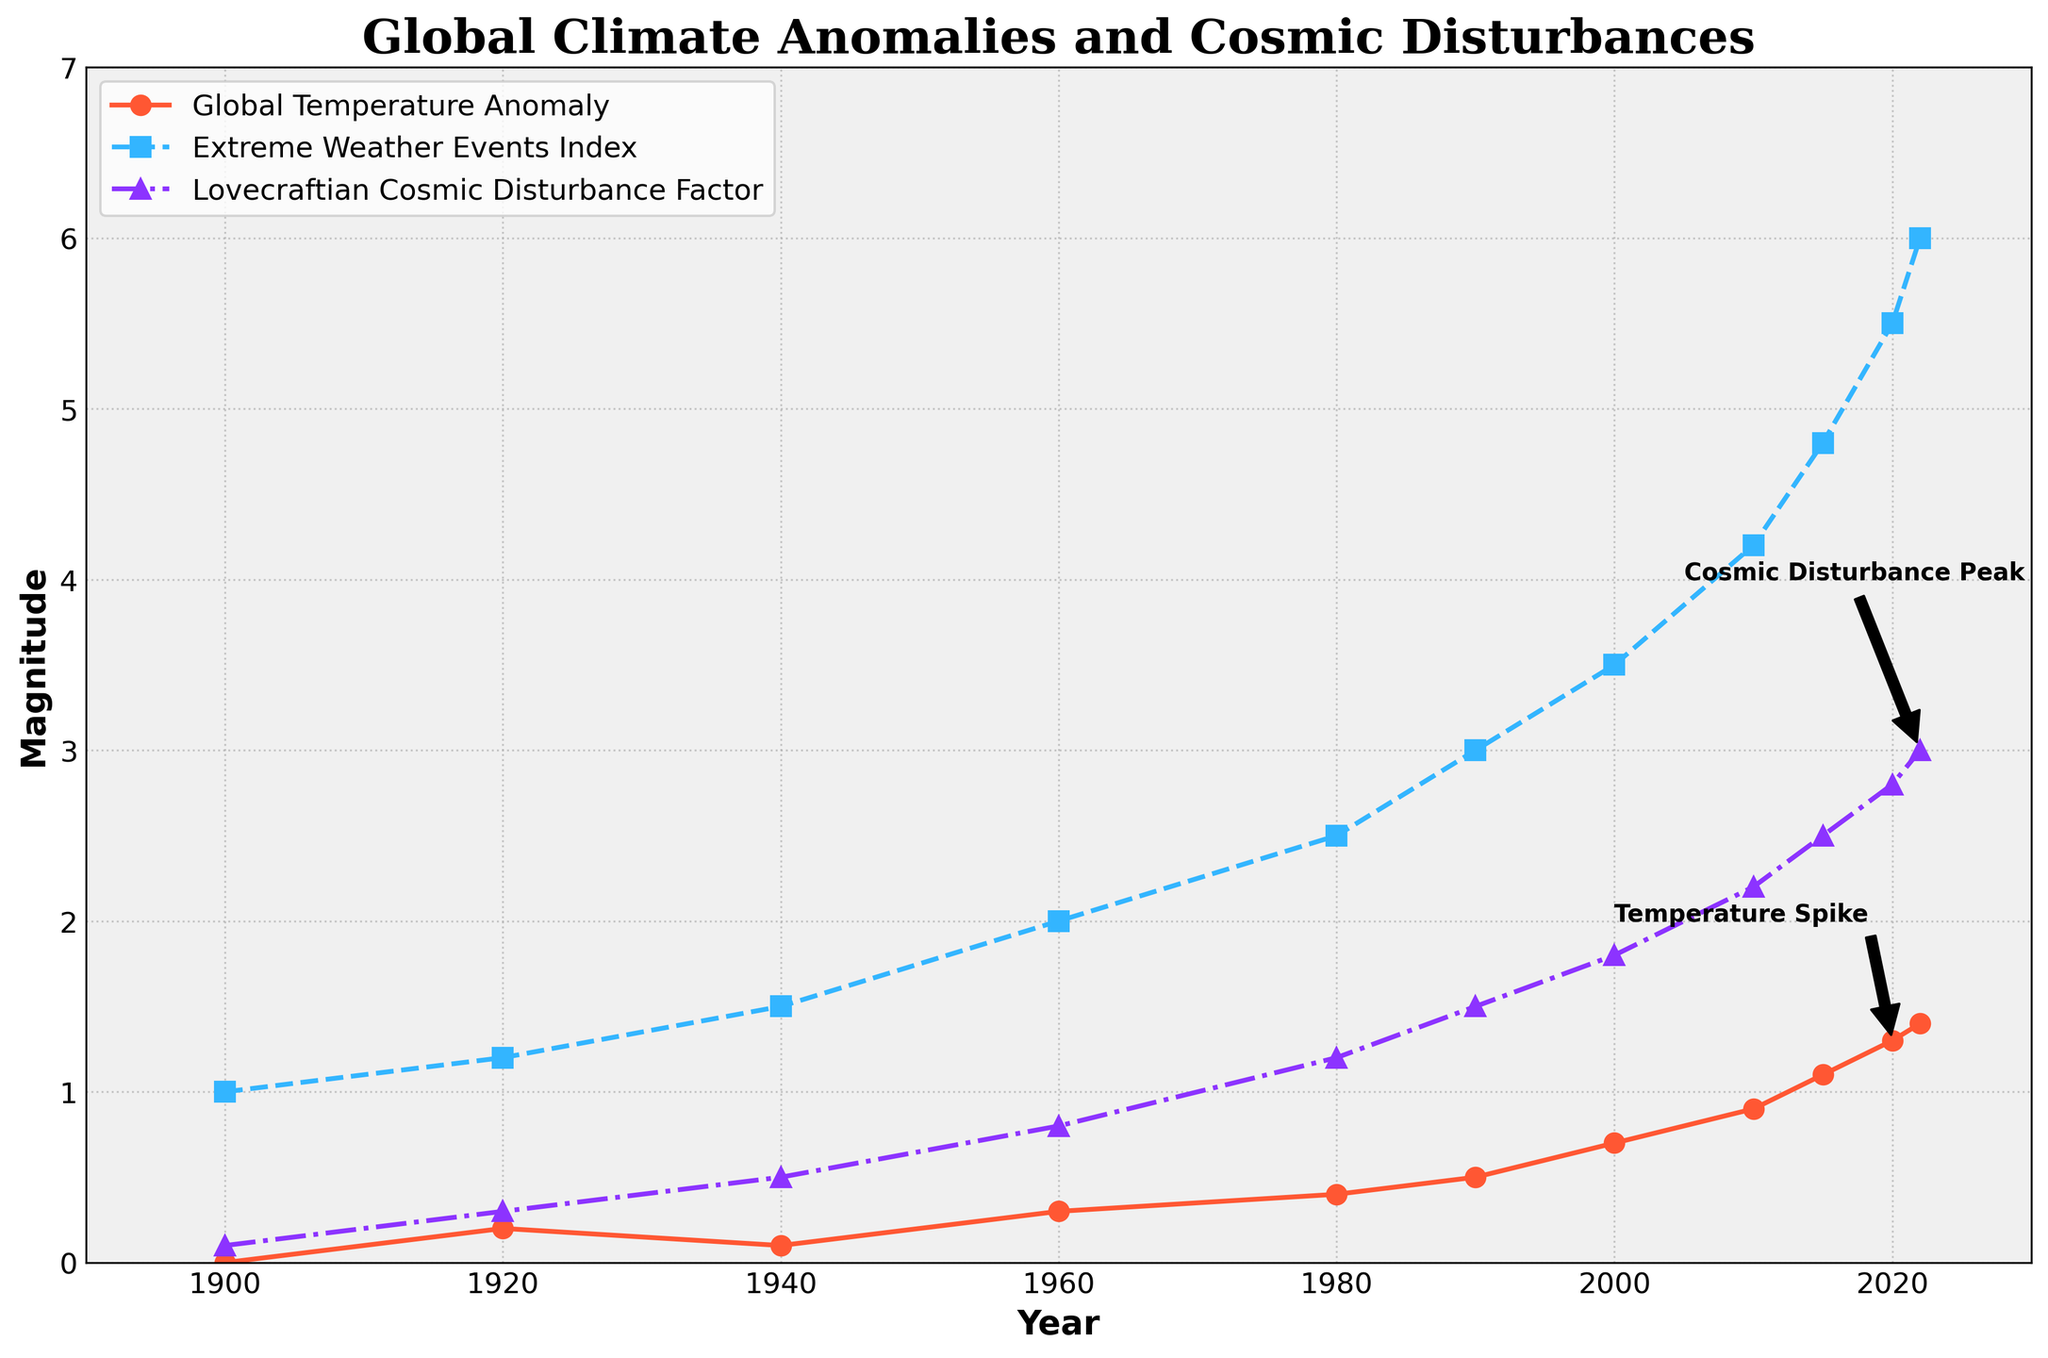what is the range of the Global Temperature Anomaly from 1900 to 2022? The range is the difference between the maximum and minimum values. From the figure, the minimum value is 0.0 in 1900, and the maximum value is 1.4 in 2022. Therefore, the range is 1.4 - 0.0 = 1.4
Answer: 1.4 which year shows a noticeable spike in the Extreme Weather Events Index? From the figure, a noticeable spike in the Extreme Weather Events Index can be seen around 2010, where the index jumps from 3.5 in 2000 to 4.2 in 2010.
Answer: 2010 compare the trends: did the Global Temperature Anomaly or the Extreme Weather Events Index increase more rapidly between 1980 and 2020? To determine which increased more rapidly, we need to compare the changes in both variables. The Global Temperature Anomaly increased from 0.4 in 1980 to 1.3 in 2020, an increase of 0.9. The Extreme Weather Events Index increased from 2.5 in 1980 to 5.5 in 2020, an increase of 3.0. The Extreme Weather Events Index increased more rapidly.
Answer: Extreme Weather Events Index what is the relationship between the Lovecraftian Cosmic Disturbance Factor and the Global Temperature Anomaly in 2022? In 2022, the Lovecraftian Cosmic Disturbance Factor is 3.0, and the Global Temperature Anomaly is 1.4. The relationship observed is that both increase over time, suggesting a potential correlation or dependency.
Answer: Both increased which index shows the highest variability throughout the period 1900-2022? Variability can be assessed by observing the fluctuations in values over time. Both the Global Temperature Anomaly and Extreme Weather Events Index have significant trends, but the Extreme Weather Events Index shows larger fluctuations and a steeper increase, indicating higher variability.
Answer: Extreme Weather Events Index compare the Global Temperature Anomaly and the Lovecraftian Cosmic Disturbance Factor in 2000. which one was higher? In 2000, the Global Temperature Anomaly was 0.7, and the Lovecraftian Cosmic Disturbance Factor was 1.8. Therefore, the Lovecraftian Cosmic Disturbance Factor was higher.
Answer: Lovecraftian Cosmic Disturbance Factor what visual element indicates an important event in the Global Temperature Anomaly plot for the year 2020? The figure uses an annotation labeled 'Temperature Spike' with an arrow pointing to the data point for the year 2020, indicating a significant event.
Answer: Annotation and arrow calculate the average rate of increase in the Extreme Weather Events Index per decade from 1900 to 2022. From 1900 to 2022, there are 12 decades. The Extreme Weather Events Index increased from 1.0 in 1900 to 6.0 in 2022, an increase of 5.0. The average rate of increase per decade is 5.0 / 12 = 0.417.
Answer: 0.417 between which consecutive decades did the Lovecraftian Cosmic Disturbance Factor increase the most? Comparing each consecutive pair: 1900-1920 increased by 0.2, 1920-1940 increased by 0.2, 1940-1960 increased by 0.3, 1960-1980 increased by 0.4, 1980-1990 increased by 0.3, 1990-2000 increased by 0.3, 2000-2010 increased by 0.4, 2010-2015 increased by 0.3, 2015-2020 increased by 0.3, 2020-2022 increased by 0.2. The most substantial increase occurred between 1960-1980 and 2000-2010, where it increased by 0.4 each.
Answer: 1960-1980 and 2000-2010 what can be inferred from the alignment of trends in all three indices between 2000 and 2022? All three indices (Global Temperature Anomaly, Extreme Weather Events Index, and Lovecraftian Cosmic Disturbance Factor) show an increasing trend between 2000 and 2022, implying that as the global temperature anomaly increases, both extreme weather events and cosmic disturbances also intensify. This alignment may indicate a potential correlation between them.
Answer: Correlation and intensification 